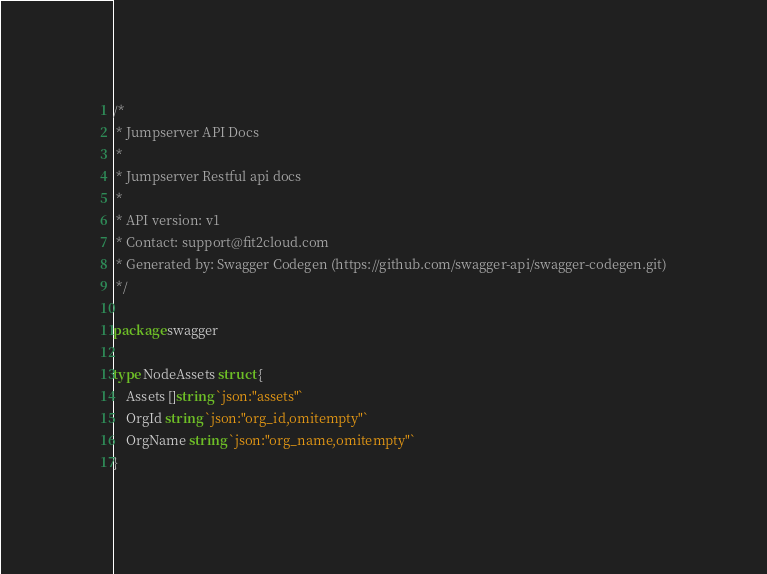<code> <loc_0><loc_0><loc_500><loc_500><_Go_>/*
 * Jumpserver API Docs
 *
 * Jumpserver Restful api docs
 *
 * API version: v1
 * Contact: support@fit2cloud.com
 * Generated by: Swagger Codegen (https://github.com/swagger-api/swagger-codegen.git)
 */

package swagger

type NodeAssets struct {
	Assets []string `json:"assets"`
	OrgId string `json:"org_id,omitempty"`
	OrgName string `json:"org_name,omitempty"`
}
</code> 